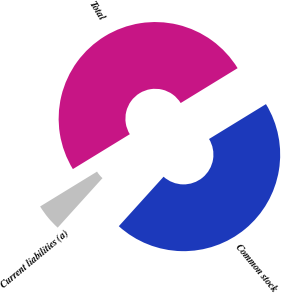<chart> <loc_0><loc_0><loc_500><loc_500><pie_chart><fcel>Current liabilities (a)<fcel>Common stock<fcel>Total<nl><fcel>4.55%<fcel>45.45%<fcel>50.0%<nl></chart> 